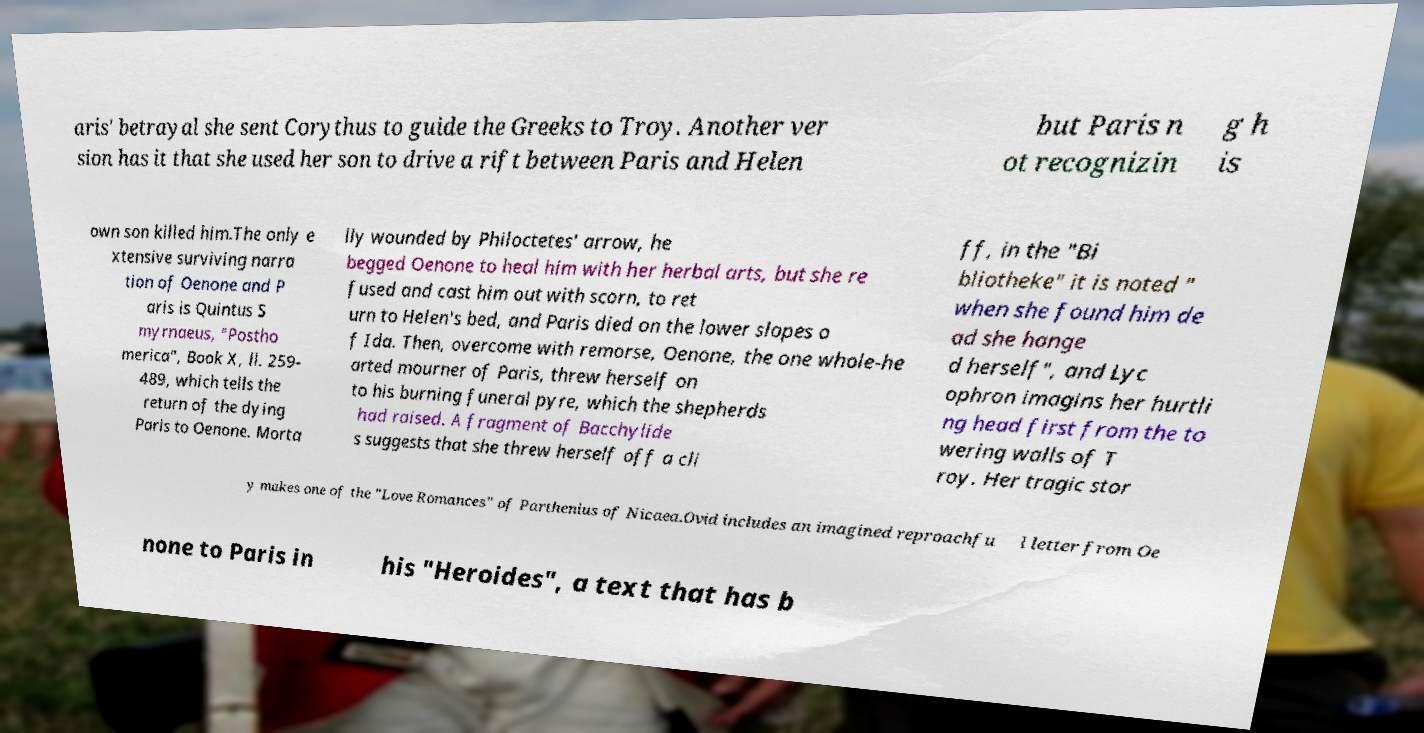Please identify and transcribe the text found in this image. aris' betrayal she sent Corythus to guide the Greeks to Troy. Another ver sion has it that she used her son to drive a rift between Paris and Helen but Paris n ot recognizin g h is own son killed him.The only e xtensive surviving narra tion of Oenone and P aris is Quintus S myrnaeus, "Postho merica", Book X, ll. 259- 489, which tells the return of the dying Paris to Oenone. Morta lly wounded by Philoctetes' arrow, he begged Oenone to heal him with her herbal arts, but she re fused and cast him out with scorn, to ret urn to Helen's bed, and Paris died on the lower slopes o f Ida. Then, overcome with remorse, Oenone, the one whole-he arted mourner of Paris, threw herself on to his burning funeral pyre, which the shepherds had raised. A fragment of Bacchylide s suggests that she threw herself off a cli ff, in the "Bi bliotheke" it is noted " when she found him de ad she hange d herself", and Lyc ophron imagins her hurtli ng head first from the to wering walls of T roy. Her tragic stor y makes one of the "Love Romances" of Parthenius of Nicaea.Ovid includes an imagined reproachfu l letter from Oe none to Paris in his "Heroides", a text that has b 